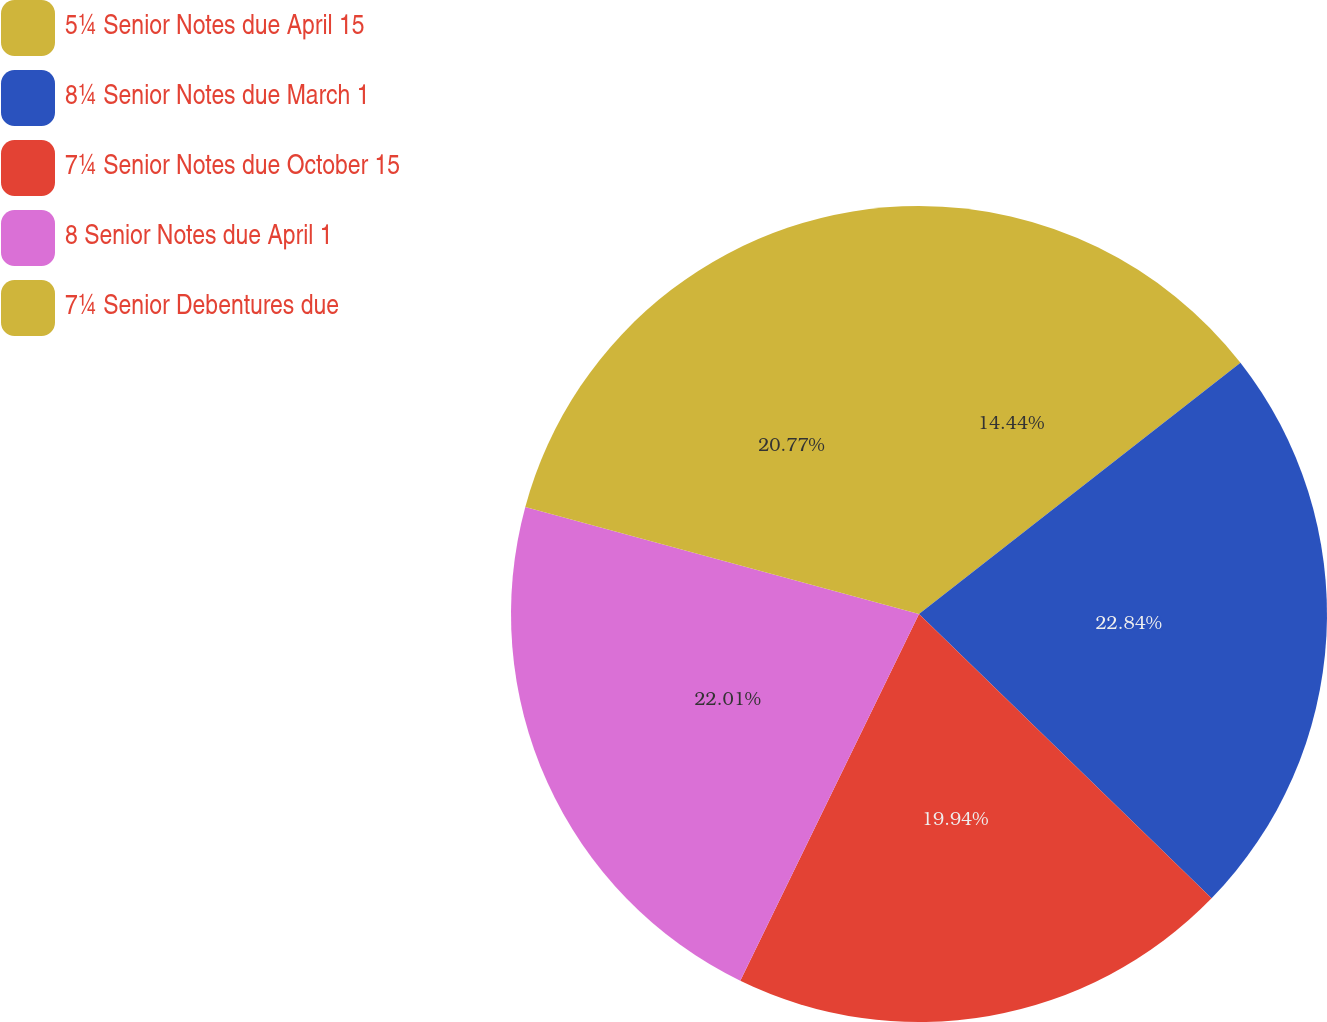<chart> <loc_0><loc_0><loc_500><loc_500><pie_chart><fcel>5¼ Senior Notes due April 15<fcel>8¼ Senior Notes due March 1<fcel>7¼ Senior Notes due October 15<fcel>8 Senior Notes due April 1<fcel>7¼ Senior Debentures due<nl><fcel>14.44%<fcel>22.83%<fcel>19.94%<fcel>22.01%<fcel>20.77%<nl></chart> 